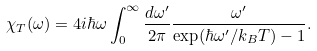Convert formula to latex. <formula><loc_0><loc_0><loc_500><loc_500>\chi _ { T } ( \omega ) = 4 i \hbar { \omega } \int _ { 0 } ^ { \infty } \frac { d \omega ^ { \prime } } { 2 \pi } \frac { \omega ^ { \prime } } { \exp ( \hbar { \omega } ^ { \prime } / k _ { B } T ) - 1 } .</formula> 